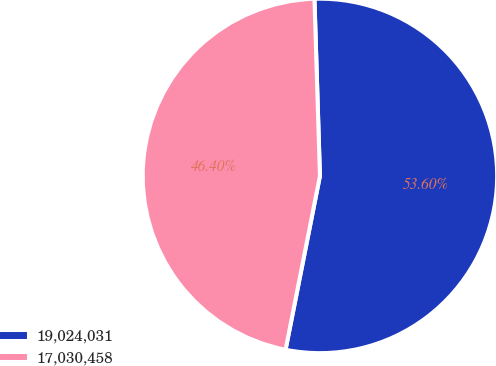Convert chart. <chart><loc_0><loc_0><loc_500><loc_500><pie_chart><fcel>19,024,031<fcel>17,030,458<nl><fcel>53.6%<fcel>46.4%<nl></chart> 